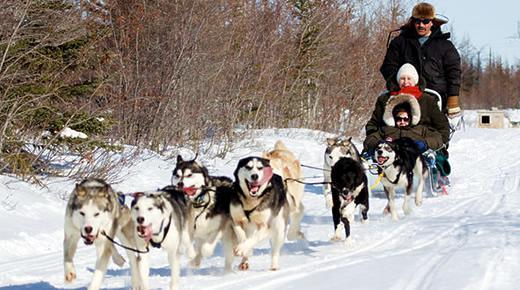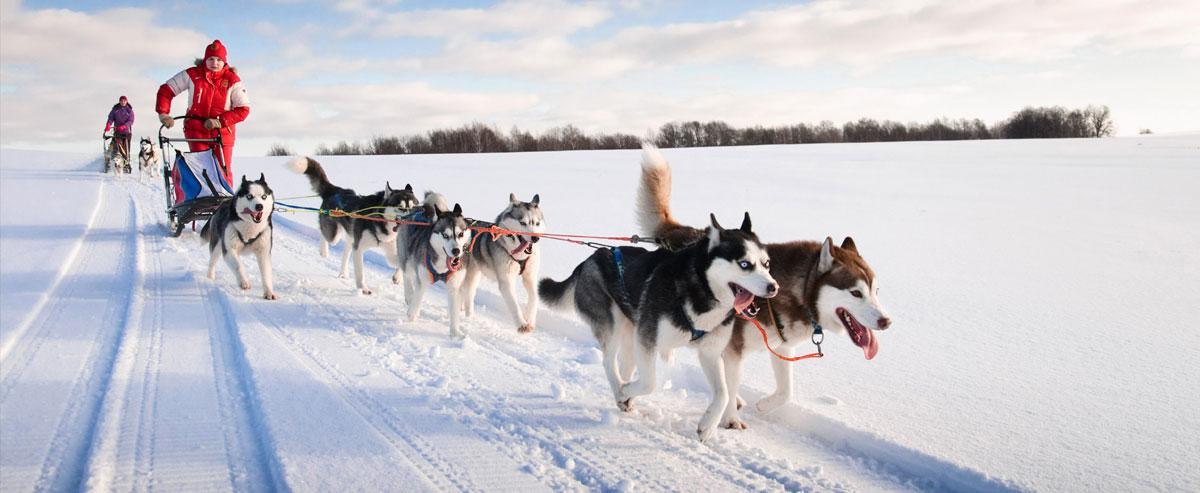The first image is the image on the left, the second image is the image on the right. Given the left and right images, does the statement "At least one rider wearing a fur-trimmed head covering is visible in one dog sled image, and the front-most sled in the other image has no seated passenger." hold true? Answer yes or no. Yes. The first image is the image on the left, the second image is the image on the right. Considering the images on both sides, is "There are multiple persons being pulled by the dogs in the image on the left." valid? Answer yes or no. Yes. 